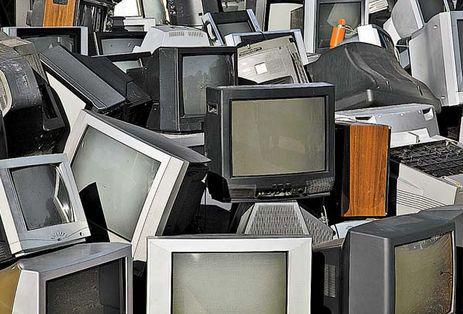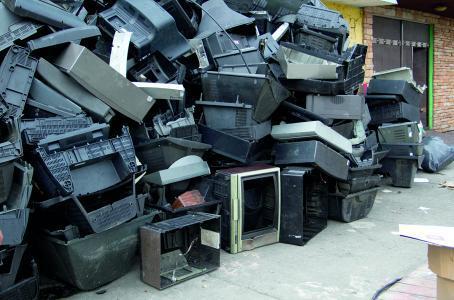The first image is the image on the left, the second image is the image on the right. Analyze the images presented: Is the assertion "The televisions in each of the images are stacked up in piles." valid? Answer yes or no. Yes. The first image is the image on the left, the second image is the image on the right. Examine the images to the left and right. Is the description "there is a pile of old tv's outside in front of a brick building" accurate? Answer yes or no. Yes. 